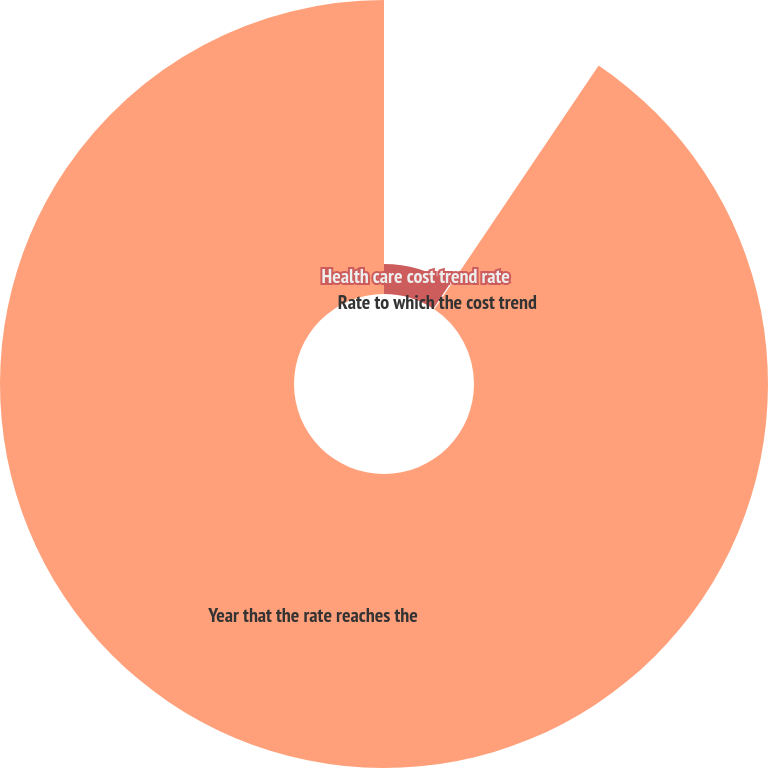Convert chart. <chart><loc_0><loc_0><loc_500><loc_500><pie_chart><fcel>Health care cost trend rate<fcel>Rate to which the cost trend<fcel>Year that the rate reaches the<nl><fcel>9.24%<fcel>0.2%<fcel>90.56%<nl></chart> 